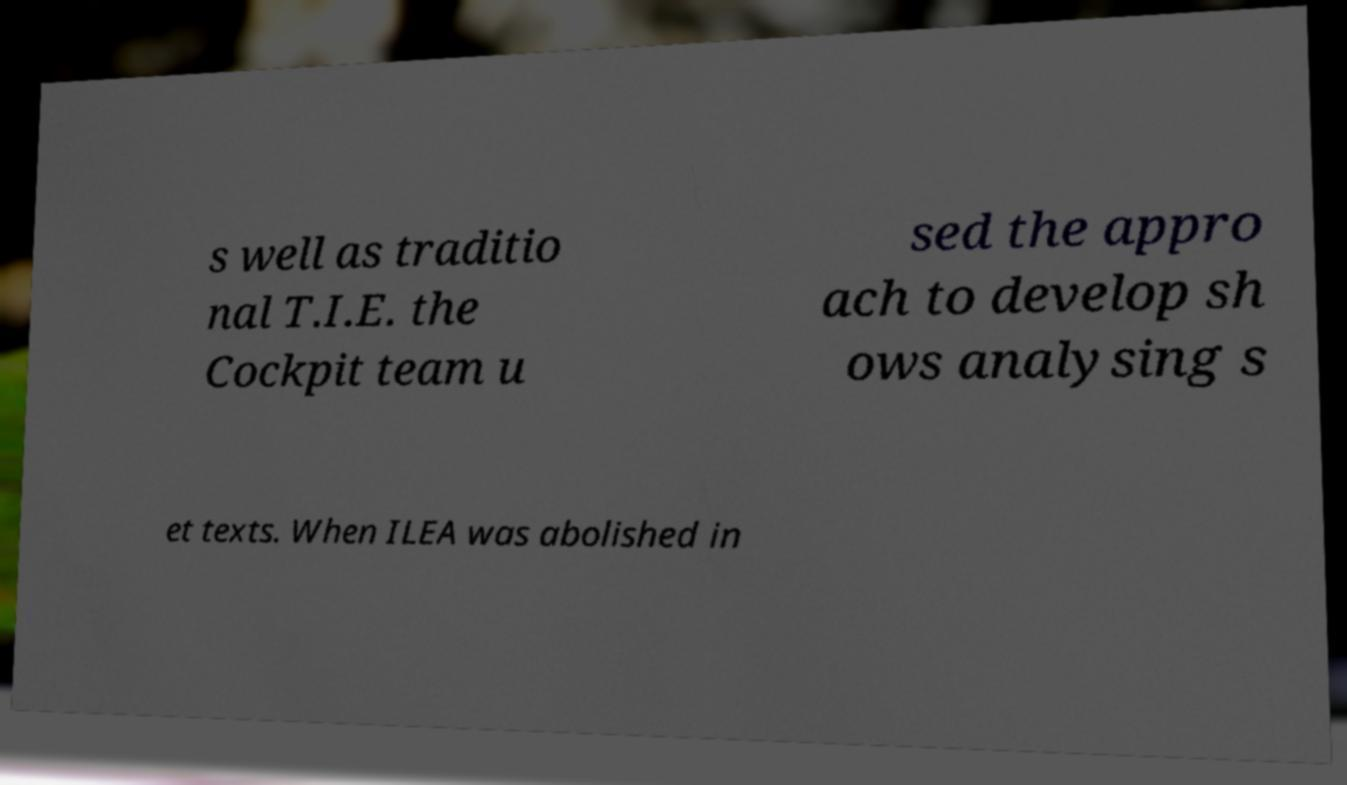I need the written content from this picture converted into text. Can you do that? s well as traditio nal T.I.E. the Cockpit team u sed the appro ach to develop sh ows analysing s et texts. When ILEA was abolished in 